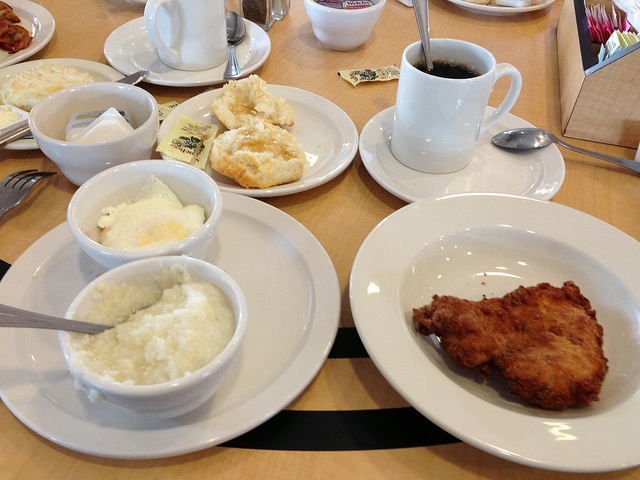Describe the objects in this image and their specific colors. I can see bowl in tan, lightgray, maroon, and darkgray tones, dining table in tan, olive, and black tones, bowl in tan, darkgray, and lightgray tones, cup in tan, darkgray, and lightgray tones, and bowl in tan, lightgray, and darkgray tones in this image. 